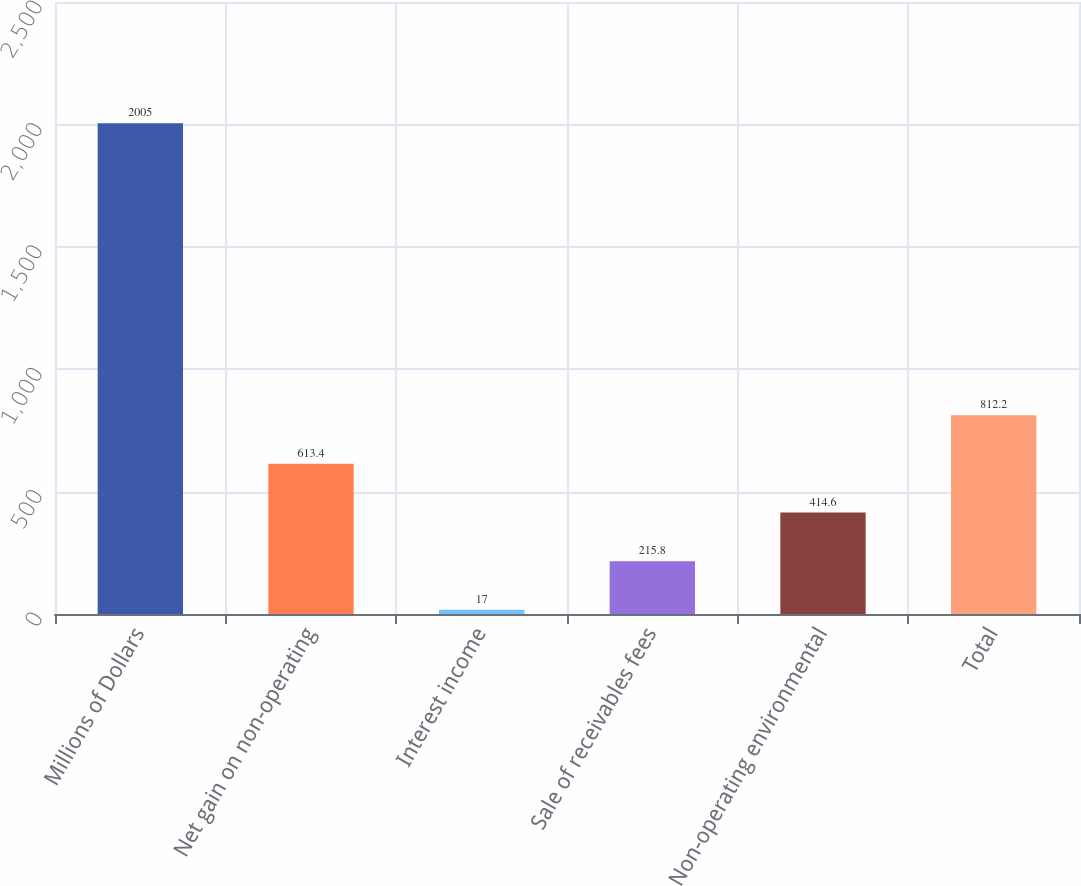Convert chart. <chart><loc_0><loc_0><loc_500><loc_500><bar_chart><fcel>Millions of Dollars<fcel>Net gain on non-operating<fcel>Interest income<fcel>Sale of receivables fees<fcel>Non-operating environmental<fcel>Total<nl><fcel>2005<fcel>613.4<fcel>17<fcel>215.8<fcel>414.6<fcel>812.2<nl></chart> 